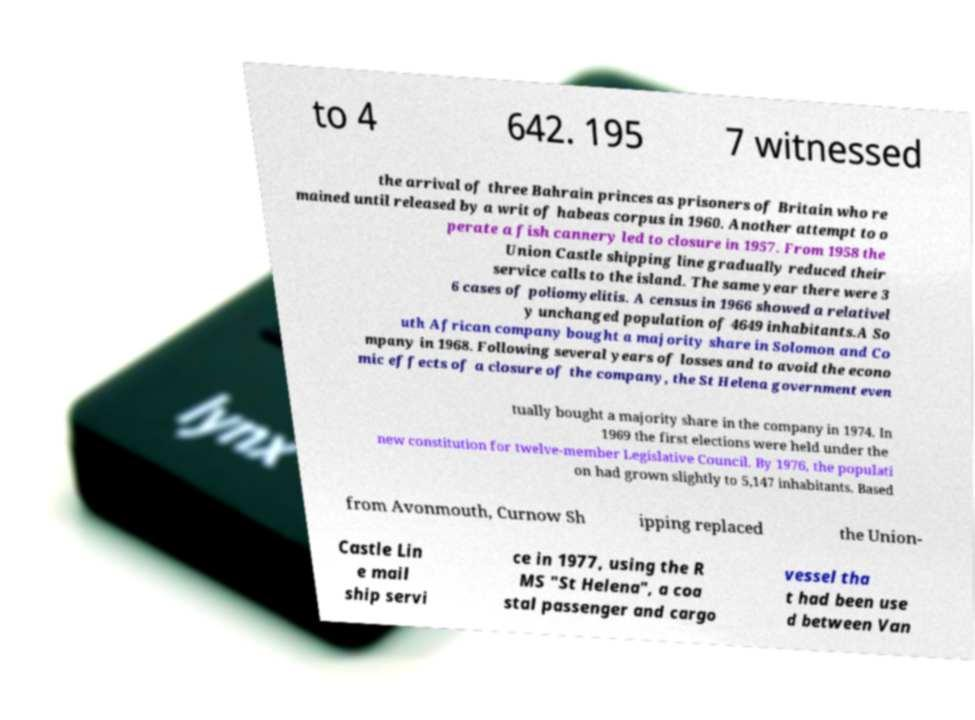Please identify and transcribe the text found in this image. to 4 642. 195 7 witnessed the arrival of three Bahrain princes as prisoners of Britain who re mained until released by a writ of habeas corpus in 1960. Another attempt to o perate a fish cannery led to closure in 1957. From 1958 the Union Castle shipping line gradually reduced their service calls to the island. The same year there were 3 6 cases of poliomyelitis. A census in 1966 showed a relativel y unchanged population of 4649 inhabitants.A So uth African company bought a majority share in Solomon and Co mpany in 1968. Following several years of losses and to avoid the econo mic effects of a closure of the company, the St Helena government even tually bought a majority share in the company in 1974. In 1969 the first elections were held under the new constitution for twelve-member Legislative Council. By 1976, the populati on had grown slightly to 5,147 inhabitants. Based from Avonmouth, Curnow Sh ipping replaced the Union- Castle Lin e mail ship servi ce in 1977, using the R MS "St Helena", a coa stal passenger and cargo vessel tha t had been use d between Van 